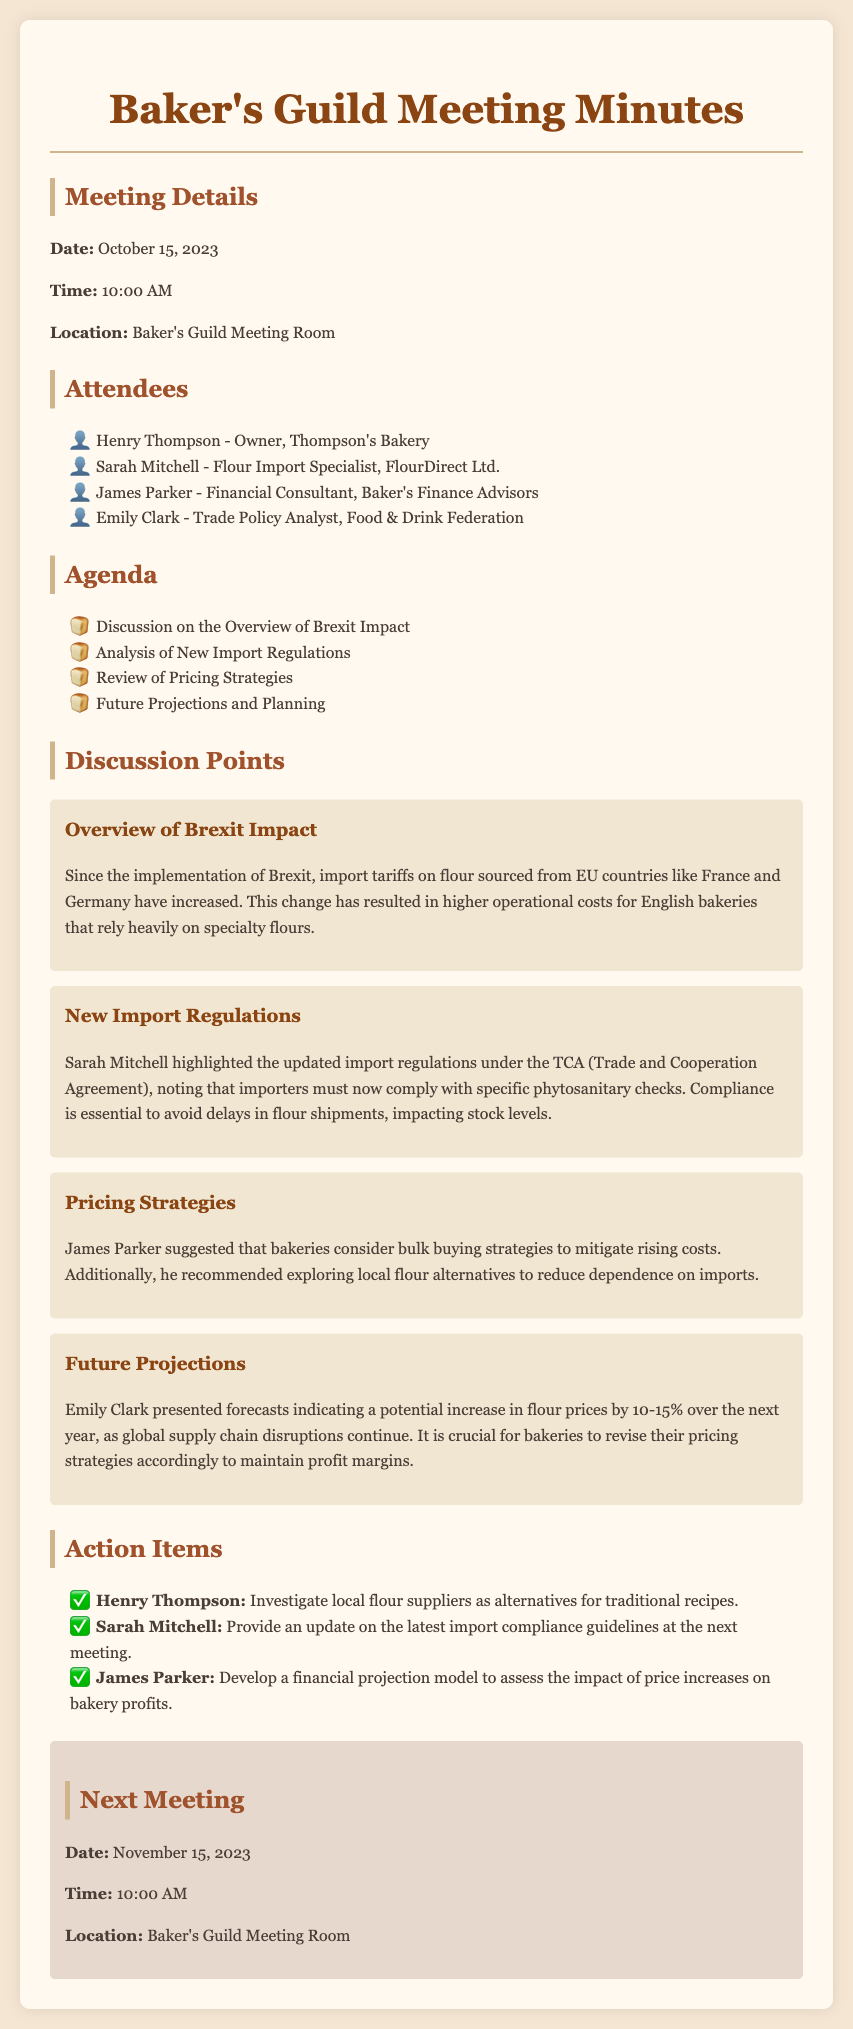What is the meeting date? The meeting date is stated in the document under "Meeting Details."
Answer: October 15, 2023 Who is the Flour Import Specialist? The name of the Flour Import Specialist is listed in the "Attendees" section.
Answer: Sarah Mitchell What are the projected flour price increases? Future price projections are mentioned in the "Future Projections" discussion point.
Answer: 10-15% What is the location of the next meeting? The location for the next meeting can be found in the "Next Meeting" section.
Answer: Baker's Guild Meeting Room What action item is assigned to Henry Thompson? The action items section lists tasks assigned to individuals, including Henry Thompson.
Answer: Investigate local flour suppliers as alternatives for traditional recipes What is a suggested pricing strategy? The discussion point on pricing strategies suggests methods for bakeries to mitigate costs.
Answer: Bulk buying strategies What compliance is essential for importers? Specific compliance requirements for importers are discussed in the "New Import Regulations" point.
Answer: Phytosanitary checks Who provided the financial projections? The person presenting the financial projections is mentioned in the "Future Projections" discussion point.
Answer: Emily Clark 